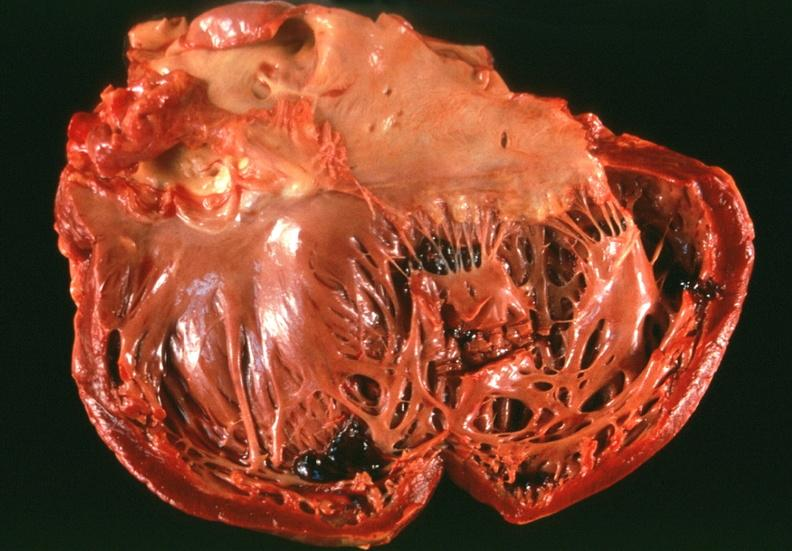how is congestive heart failure , left dilatation?
Answer the question using a single word or phrase. Ventricular 